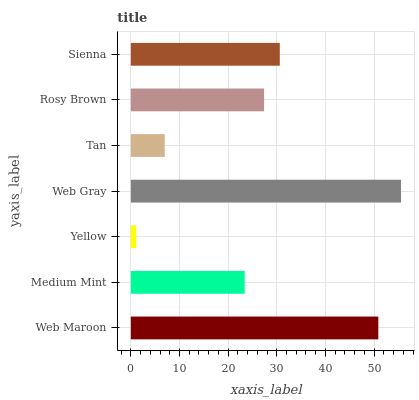Is Yellow the minimum?
Answer yes or no. Yes. Is Web Gray the maximum?
Answer yes or no. Yes. Is Medium Mint the minimum?
Answer yes or no. No. Is Medium Mint the maximum?
Answer yes or no. No. Is Web Maroon greater than Medium Mint?
Answer yes or no. Yes. Is Medium Mint less than Web Maroon?
Answer yes or no. Yes. Is Medium Mint greater than Web Maroon?
Answer yes or no. No. Is Web Maroon less than Medium Mint?
Answer yes or no. No. Is Rosy Brown the high median?
Answer yes or no. Yes. Is Rosy Brown the low median?
Answer yes or no. Yes. Is Sienna the high median?
Answer yes or no. No. Is Web Maroon the low median?
Answer yes or no. No. 